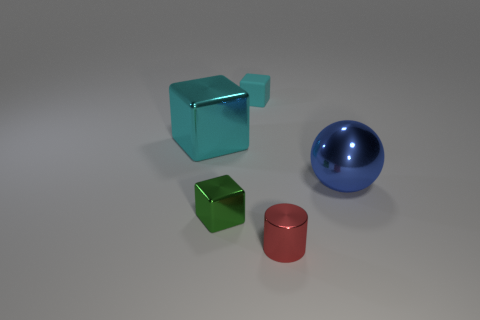Is there another big cyan object that has the same shape as the matte object?
Make the answer very short. Yes. There is a shiny cube behind the small green block; is its size the same as the shiny cube that is in front of the big shiny block?
Provide a short and direct response. No. What is the shape of the cyan object that is on the left side of the small block in front of the blue ball?
Your answer should be compact. Cube. How many red metallic cylinders have the same size as the green object?
Ensure brevity in your answer.  1. Are any cyan metal cylinders visible?
Ensure brevity in your answer.  No. Is there any other thing of the same color as the cylinder?
Offer a very short reply. No. There is a small red thing that is the same material as the green thing; what shape is it?
Your answer should be compact. Cylinder. What color is the block in front of the big shiny object that is behind the large object to the right of the small red metallic cylinder?
Provide a succinct answer. Green. Is the number of large metal balls that are to the left of the small red cylinder the same as the number of brown shiny objects?
Make the answer very short. Yes. Is there any other thing that has the same material as the tiny cyan thing?
Your answer should be very brief. No. 